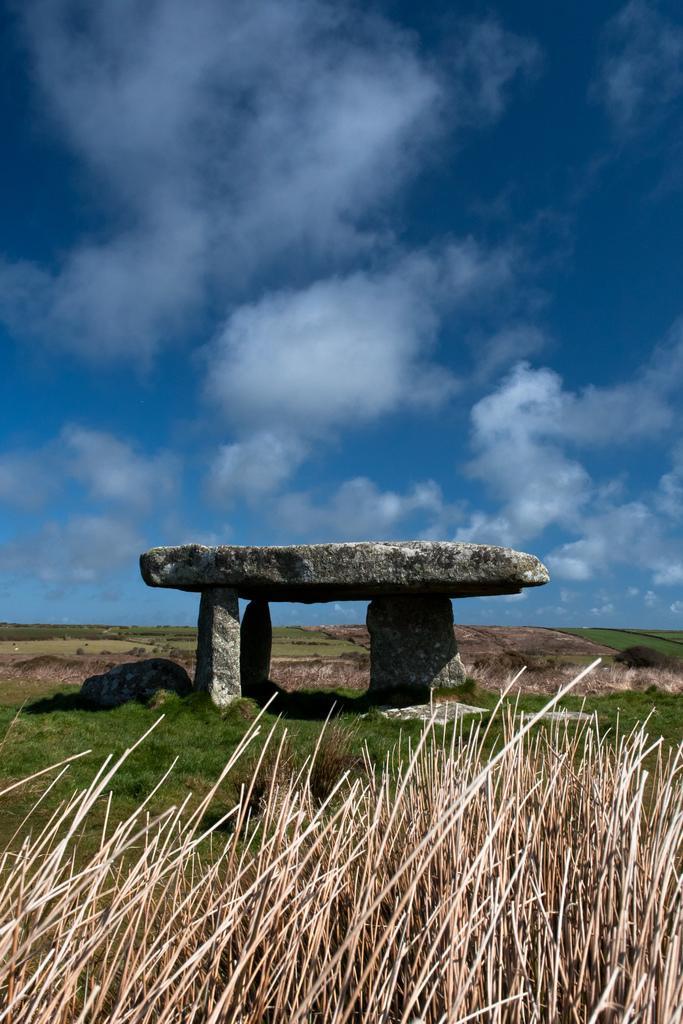In one or two sentences, can you explain what this image depicts? This is grass and there are rocks. In the background there is sky with clouds. 